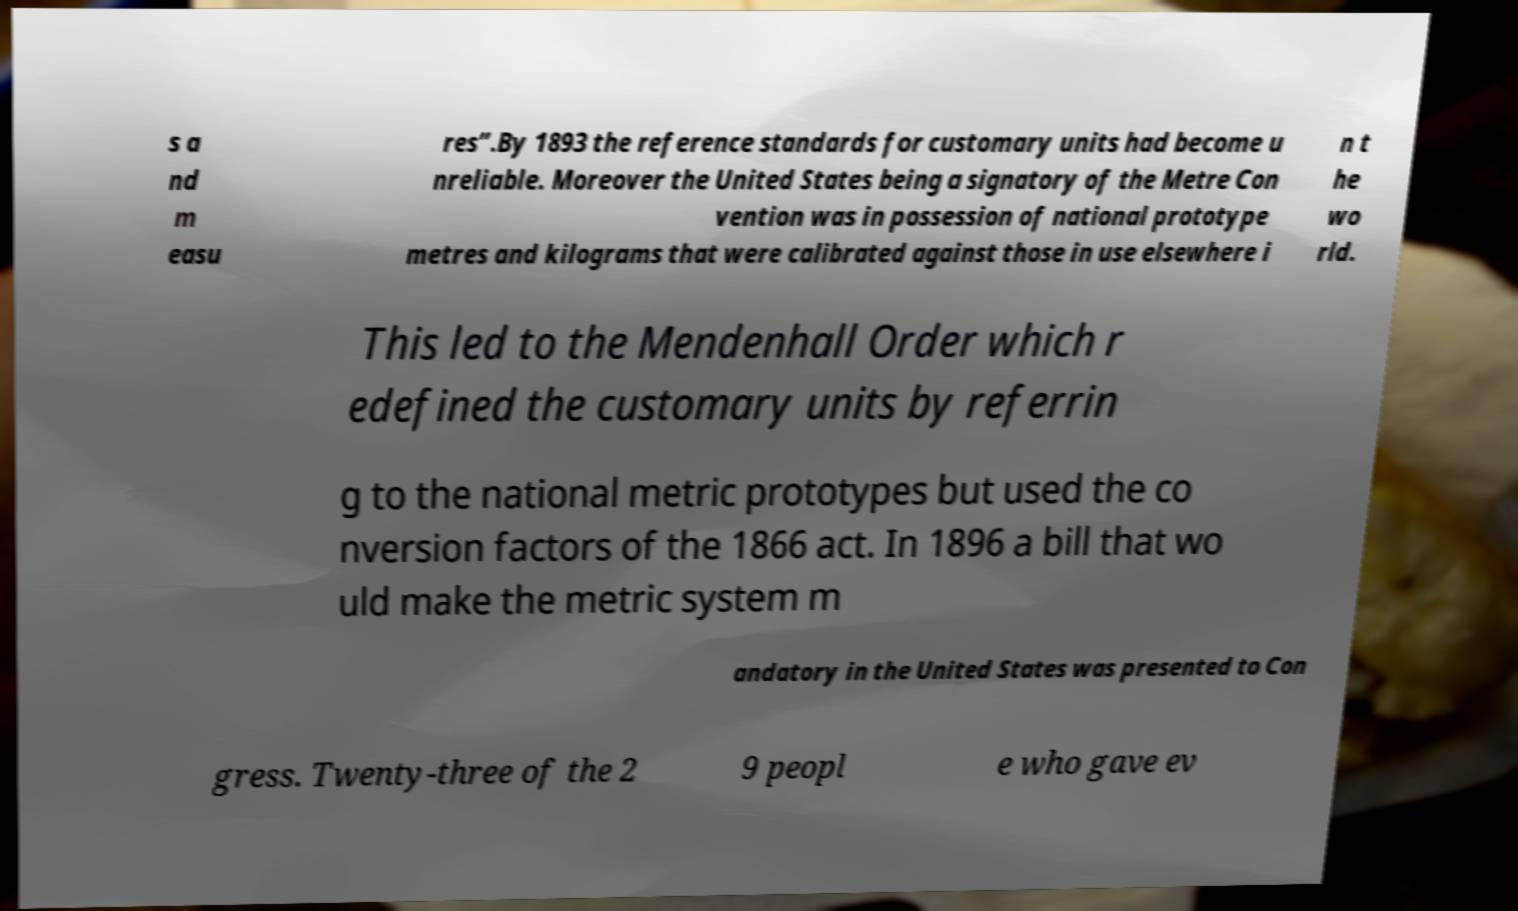I need the written content from this picture converted into text. Can you do that? s a nd m easu res”.By 1893 the reference standards for customary units had become u nreliable. Moreover the United States being a signatory of the Metre Con vention was in possession of national prototype metres and kilograms that were calibrated against those in use elsewhere i n t he wo rld. This led to the Mendenhall Order which r edefined the customary units by referrin g to the national metric prototypes but used the co nversion factors of the 1866 act. In 1896 a bill that wo uld make the metric system m andatory in the United States was presented to Con gress. Twenty-three of the 2 9 peopl e who gave ev 